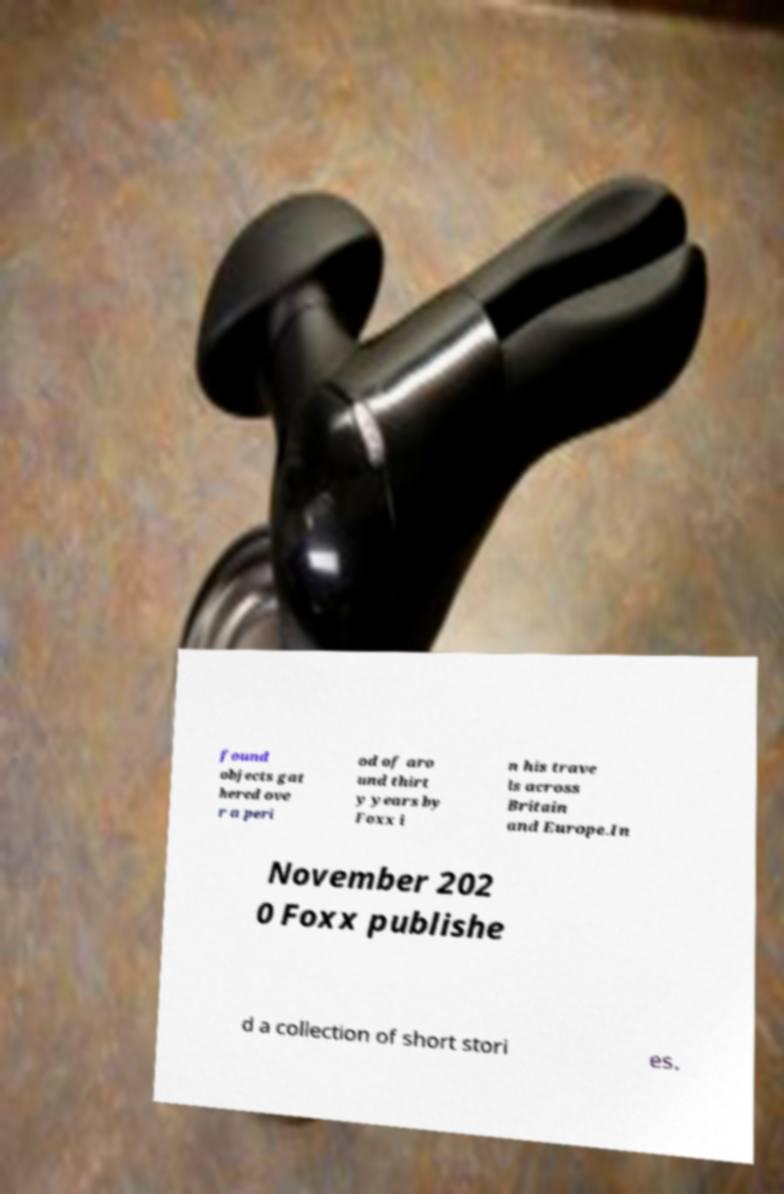I need the written content from this picture converted into text. Can you do that? found objects gat hered ove r a peri od of aro und thirt y years by Foxx i n his trave ls across Britain and Europe.In November 202 0 Foxx publishe d a collection of short stori es. 